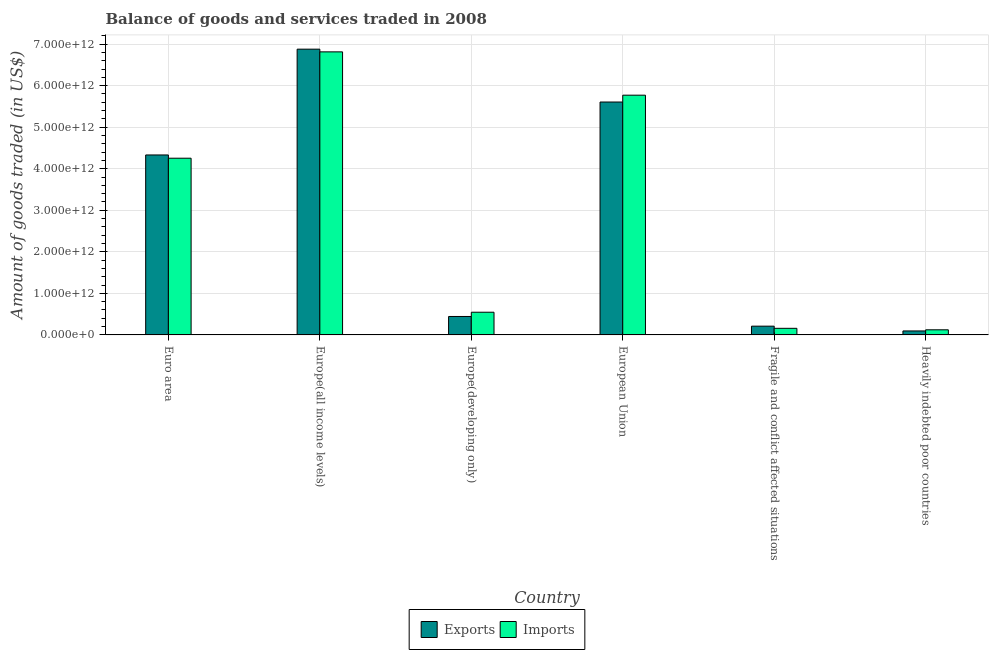How many different coloured bars are there?
Offer a terse response. 2. Are the number of bars on each tick of the X-axis equal?
Provide a short and direct response. Yes. How many bars are there on the 4th tick from the right?
Provide a short and direct response. 2. What is the label of the 1st group of bars from the left?
Your answer should be compact. Euro area. In how many cases, is the number of bars for a given country not equal to the number of legend labels?
Offer a very short reply. 0. What is the amount of goods exported in Europe(all income levels)?
Your response must be concise. 6.88e+12. Across all countries, what is the maximum amount of goods imported?
Keep it short and to the point. 6.81e+12. Across all countries, what is the minimum amount of goods exported?
Offer a terse response. 9.56e+1. In which country was the amount of goods exported maximum?
Make the answer very short. Europe(all income levels). In which country was the amount of goods imported minimum?
Your answer should be very brief. Heavily indebted poor countries. What is the total amount of goods imported in the graph?
Your answer should be very brief. 1.77e+13. What is the difference between the amount of goods exported in Europe(developing only) and that in European Union?
Offer a very short reply. -5.16e+12. What is the difference between the amount of goods exported in Euro area and the amount of goods imported in European Union?
Provide a short and direct response. -1.44e+12. What is the average amount of goods exported per country?
Keep it short and to the point. 2.93e+12. What is the difference between the amount of goods exported and amount of goods imported in Fragile and conflict affected situations?
Offer a terse response. 5.19e+1. What is the ratio of the amount of goods imported in European Union to that in Fragile and conflict affected situations?
Keep it short and to the point. 36.34. Is the difference between the amount of goods exported in Europe(all income levels) and Fragile and conflict affected situations greater than the difference between the amount of goods imported in Europe(all income levels) and Fragile and conflict affected situations?
Your answer should be very brief. Yes. What is the difference between the highest and the second highest amount of goods exported?
Your answer should be compact. 1.27e+12. What is the difference between the highest and the lowest amount of goods imported?
Give a very brief answer. 6.69e+12. What does the 2nd bar from the left in Europe(all income levels) represents?
Your answer should be very brief. Imports. What does the 2nd bar from the right in European Union represents?
Provide a succinct answer. Exports. How many bars are there?
Give a very brief answer. 12. How many countries are there in the graph?
Offer a very short reply. 6. What is the difference between two consecutive major ticks on the Y-axis?
Keep it short and to the point. 1.00e+12. Where does the legend appear in the graph?
Offer a very short reply. Bottom center. How many legend labels are there?
Offer a terse response. 2. What is the title of the graph?
Provide a succinct answer. Balance of goods and services traded in 2008. Does "Female labor force" appear as one of the legend labels in the graph?
Ensure brevity in your answer.  No. What is the label or title of the X-axis?
Ensure brevity in your answer.  Country. What is the label or title of the Y-axis?
Keep it short and to the point. Amount of goods traded (in US$). What is the Amount of goods traded (in US$) of Exports in Euro area?
Offer a very short reply. 4.33e+12. What is the Amount of goods traded (in US$) in Imports in Euro area?
Offer a terse response. 4.25e+12. What is the Amount of goods traded (in US$) of Exports in Europe(all income levels)?
Your answer should be compact. 6.88e+12. What is the Amount of goods traded (in US$) in Imports in Europe(all income levels)?
Offer a terse response. 6.81e+12. What is the Amount of goods traded (in US$) in Exports in Europe(developing only)?
Offer a terse response. 4.44e+11. What is the Amount of goods traded (in US$) of Imports in Europe(developing only)?
Offer a very short reply. 5.46e+11. What is the Amount of goods traded (in US$) in Exports in European Union?
Offer a terse response. 5.61e+12. What is the Amount of goods traded (in US$) of Imports in European Union?
Offer a very short reply. 5.77e+12. What is the Amount of goods traded (in US$) of Exports in Fragile and conflict affected situations?
Provide a succinct answer. 2.11e+11. What is the Amount of goods traded (in US$) in Imports in Fragile and conflict affected situations?
Offer a terse response. 1.59e+11. What is the Amount of goods traded (in US$) in Exports in Heavily indebted poor countries?
Your answer should be very brief. 9.56e+1. What is the Amount of goods traded (in US$) in Imports in Heavily indebted poor countries?
Your response must be concise. 1.23e+11. Across all countries, what is the maximum Amount of goods traded (in US$) in Exports?
Your answer should be compact. 6.88e+12. Across all countries, what is the maximum Amount of goods traded (in US$) of Imports?
Give a very brief answer. 6.81e+12. Across all countries, what is the minimum Amount of goods traded (in US$) of Exports?
Offer a very short reply. 9.56e+1. Across all countries, what is the minimum Amount of goods traded (in US$) of Imports?
Offer a very short reply. 1.23e+11. What is the total Amount of goods traded (in US$) in Exports in the graph?
Keep it short and to the point. 1.76e+13. What is the total Amount of goods traded (in US$) of Imports in the graph?
Your response must be concise. 1.77e+13. What is the difference between the Amount of goods traded (in US$) of Exports in Euro area and that in Europe(all income levels)?
Give a very brief answer. -2.55e+12. What is the difference between the Amount of goods traded (in US$) in Imports in Euro area and that in Europe(all income levels)?
Provide a short and direct response. -2.56e+12. What is the difference between the Amount of goods traded (in US$) of Exports in Euro area and that in Europe(developing only)?
Keep it short and to the point. 3.89e+12. What is the difference between the Amount of goods traded (in US$) of Imports in Euro area and that in Europe(developing only)?
Ensure brevity in your answer.  3.71e+12. What is the difference between the Amount of goods traded (in US$) of Exports in Euro area and that in European Union?
Your answer should be very brief. -1.27e+12. What is the difference between the Amount of goods traded (in US$) of Imports in Euro area and that in European Union?
Your answer should be very brief. -1.52e+12. What is the difference between the Amount of goods traded (in US$) of Exports in Euro area and that in Fragile and conflict affected situations?
Give a very brief answer. 4.12e+12. What is the difference between the Amount of goods traded (in US$) of Imports in Euro area and that in Fragile and conflict affected situations?
Make the answer very short. 4.09e+12. What is the difference between the Amount of goods traded (in US$) of Exports in Euro area and that in Heavily indebted poor countries?
Provide a succinct answer. 4.24e+12. What is the difference between the Amount of goods traded (in US$) in Imports in Euro area and that in Heavily indebted poor countries?
Make the answer very short. 4.13e+12. What is the difference between the Amount of goods traded (in US$) in Exports in Europe(all income levels) and that in Europe(developing only)?
Offer a terse response. 6.43e+12. What is the difference between the Amount of goods traded (in US$) of Imports in Europe(all income levels) and that in Europe(developing only)?
Make the answer very short. 6.27e+12. What is the difference between the Amount of goods traded (in US$) of Exports in Europe(all income levels) and that in European Union?
Your response must be concise. 1.27e+12. What is the difference between the Amount of goods traded (in US$) of Imports in Europe(all income levels) and that in European Union?
Offer a terse response. 1.04e+12. What is the difference between the Amount of goods traded (in US$) in Exports in Europe(all income levels) and that in Fragile and conflict affected situations?
Make the answer very short. 6.67e+12. What is the difference between the Amount of goods traded (in US$) in Imports in Europe(all income levels) and that in Fragile and conflict affected situations?
Make the answer very short. 6.65e+12. What is the difference between the Amount of goods traded (in US$) in Exports in Europe(all income levels) and that in Heavily indebted poor countries?
Your answer should be compact. 6.78e+12. What is the difference between the Amount of goods traded (in US$) in Imports in Europe(all income levels) and that in Heavily indebted poor countries?
Your answer should be very brief. 6.69e+12. What is the difference between the Amount of goods traded (in US$) of Exports in Europe(developing only) and that in European Union?
Your answer should be very brief. -5.16e+12. What is the difference between the Amount of goods traded (in US$) in Imports in Europe(developing only) and that in European Union?
Provide a succinct answer. -5.22e+12. What is the difference between the Amount of goods traded (in US$) of Exports in Europe(developing only) and that in Fragile and conflict affected situations?
Make the answer very short. 2.33e+11. What is the difference between the Amount of goods traded (in US$) in Imports in Europe(developing only) and that in Fragile and conflict affected situations?
Your answer should be very brief. 3.87e+11. What is the difference between the Amount of goods traded (in US$) of Exports in Europe(developing only) and that in Heavily indebted poor countries?
Offer a very short reply. 3.48e+11. What is the difference between the Amount of goods traded (in US$) of Imports in Europe(developing only) and that in Heavily indebted poor countries?
Your response must be concise. 4.23e+11. What is the difference between the Amount of goods traded (in US$) of Exports in European Union and that in Fragile and conflict affected situations?
Offer a very short reply. 5.39e+12. What is the difference between the Amount of goods traded (in US$) of Imports in European Union and that in Fragile and conflict affected situations?
Give a very brief answer. 5.61e+12. What is the difference between the Amount of goods traded (in US$) in Exports in European Union and that in Heavily indebted poor countries?
Provide a succinct answer. 5.51e+12. What is the difference between the Amount of goods traded (in US$) of Imports in European Union and that in Heavily indebted poor countries?
Keep it short and to the point. 5.65e+12. What is the difference between the Amount of goods traded (in US$) in Exports in Fragile and conflict affected situations and that in Heavily indebted poor countries?
Make the answer very short. 1.15e+11. What is the difference between the Amount of goods traded (in US$) of Imports in Fragile and conflict affected situations and that in Heavily indebted poor countries?
Provide a short and direct response. 3.57e+1. What is the difference between the Amount of goods traded (in US$) of Exports in Euro area and the Amount of goods traded (in US$) of Imports in Europe(all income levels)?
Provide a succinct answer. -2.48e+12. What is the difference between the Amount of goods traded (in US$) in Exports in Euro area and the Amount of goods traded (in US$) in Imports in Europe(developing only)?
Your answer should be very brief. 3.79e+12. What is the difference between the Amount of goods traded (in US$) in Exports in Euro area and the Amount of goods traded (in US$) in Imports in European Union?
Ensure brevity in your answer.  -1.44e+12. What is the difference between the Amount of goods traded (in US$) in Exports in Euro area and the Amount of goods traded (in US$) in Imports in Fragile and conflict affected situations?
Give a very brief answer. 4.17e+12. What is the difference between the Amount of goods traded (in US$) in Exports in Euro area and the Amount of goods traded (in US$) in Imports in Heavily indebted poor countries?
Offer a terse response. 4.21e+12. What is the difference between the Amount of goods traded (in US$) of Exports in Europe(all income levels) and the Amount of goods traded (in US$) of Imports in Europe(developing only)?
Your response must be concise. 6.33e+12. What is the difference between the Amount of goods traded (in US$) in Exports in Europe(all income levels) and the Amount of goods traded (in US$) in Imports in European Union?
Your answer should be very brief. 1.11e+12. What is the difference between the Amount of goods traded (in US$) in Exports in Europe(all income levels) and the Amount of goods traded (in US$) in Imports in Fragile and conflict affected situations?
Offer a very short reply. 6.72e+12. What is the difference between the Amount of goods traded (in US$) in Exports in Europe(all income levels) and the Amount of goods traded (in US$) in Imports in Heavily indebted poor countries?
Ensure brevity in your answer.  6.75e+12. What is the difference between the Amount of goods traded (in US$) of Exports in Europe(developing only) and the Amount of goods traded (in US$) of Imports in European Union?
Make the answer very short. -5.33e+12. What is the difference between the Amount of goods traded (in US$) in Exports in Europe(developing only) and the Amount of goods traded (in US$) in Imports in Fragile and conflict affected situations?
Make the answer very short. 2.85e+11. What is the difference between the Amount of goods traded (in US$) of Exports in Europe(developing only) and the Amount of goods traded (in US$) of Imports in Heavily indebted poor countries?
Keep it short and to the point. 3.21e+11. What is the difference between the Amount of goods traded (in US$) of Exports in European Union and the Amount of goods traded (in US$) of Imports in Fragile and conflict affected situations?
Provide a succinct answer. 5.45e+12. What is the difference between the Amount of goods traded (in US$) in Exports in European Union and the Amount of goods traded (in US$) in Imports in Heavily indebted poor countries?
Ensure brevity in your answer.  5.48e+12. What is the difference between the Amount of goods traded (in US$) in Exports in Fragile and conflict affected situations and the Amount of goods traded (in US$) in Imports in Heavily indebted poor countries?
Ensure brevity in your answer.  8.76e+1. What is the average Amount of goods traded (in US$) in Exports per country?
Ensure brevity in your answer.  2.93e+12. What is the average Amount of goods traded (in US$) of Imports per country?
Make the answer very short. 2.94e+12. What is the difference between the Amount of goods traded (in US$) in Exports and Amount of goods traded (in US$) in Imports in Euro area?
Provide a succinct answer. 7.85e+1. What is the difference between the Amount of goods traded (in US$) of Exports and Amount of goods traded (in US$) of Imports in Europe(all income levels)?
Keep it short and to the point. 6.52e+1. What is the difference between the Amount of goods traded (in US$) of Exports and Amount of goods traded (in US$) of Imports in Europe(developing only)?
Keep it short and to the point. -1.02e+11. What is the difference between the Amount of goods traded (in US$) of Exports and Amount of goods traded (in US$) of Imports in European Union?
Your answer should be compact. -1.65e+11. What is the difference between the Amount of goods traded (in US$) of Exports and Amount of goods traded (in US$) of Imports in Fragile and conflict affected situations?
Provide a succinct answer. 5.19e+1. What is the difference between the Amount of goods traded (in US$) in Exports and Amount of goods traded (in US$) in Imports in Heavily indebted poor countries?
Make the answer very short. -2.75e+1. What is the ratio of the Amount of goods traded (in US$) of Exports in Euro area to that in Europe(all income levels)?
Make the answer very short. 0.63. What is the ratio of the Amount of goods traded (in US$) in Imports in Euro area to that in Europe(all income levels)?
Offer a terse response. 0.62. What is the ratio of the Amount of goods traded (in US$) of Exports in Euro area to that in Europe(developing only)?
Offer a terse response. 9.76. What is the ratio of the Amount of goods traded (in US$) in Imports in Euro area to that in Europe(developing only)?
Provide a short and direct response. 7.79. What is the ratio of the Amount of goods traded (in US$) in Exports in Euro area to that in European Union?
Keep it short and to the point. 0.77. What is the ratio of the Amount of goods traded (in US$) in Imports in Euro area to that in European Union?
Ensure brevity in your answer.  0.74. What is the ratio of the Amount of goods traded (in US$) in Exports in Euro area to that in Fragile and conflict affected situations?
Your answer should be compact. 20.56. What is the ratio of the Amount of goods traded (in US$) of Imports in Euro area to that in Fragile and conflict affected situations?
Give a very brief answer. 26.79. What is the ratio of the Amount of goods traded (in US$) in Exports in Euro area to that in Heavily indebted poor countries?
Ensure brevity in your answer.  45.3. What is the ratio of the Amount of goods traded (in US$) in Imports in Euro area to that in Heavily indebted poor countries?
Provide a succinct answer. 34.55. What is the ratio of the Amount of goods traded (in US$) in Exports in Europe(all income levels) to that in Europe(developing only)?
Give a very brief answer. 15.5. What is the ratio of the Amount of goods traded (in US$) in Imports in Europe(all income levels) to that in Europe(developing only)?
Make the answer very short. 12.48. What is the ratio of the Amount of goods traded (in US$) of Exports in Europe(all income levels) to that in European Union?
Offer a very short reply. 1.23. What is the ratio of the Amount of goods traded (in US$) of Imports in Europe(all income levels) to that in European Union?
Give a very brief answer. 1.18. What is the ratio of the Amount of goods traded (in US$) of Exports in Europe(all income levels) to that in Fragile and conflict affected situations?
Make the answer very short. 32.65. What is the ratio of the Amount of goods traded (in US$) of Imports in Europe(all income levels) to that in Fragile and conflict affected situations?
Give a very brief answer. 42.91. What is the ratio of the Amount of goods traded (in US$) of Exports in Europe(all income levels) to that in Heavily indebted poor countries?
Your response must be concise. 71.94. What is the ratio of the Amount of goods traded (in US$) of Imports in Europe(all income levels) to that in Heavily indebted poor countries?
Your response must be concise. 55.35. What is the ratio of the Amount of goods traded (in US$) of Exports in Europe(developing only) to that in European Union?
Offer a terse response. 0.08. What is the ratio of the Amount of goods traded (in US$) in Imports in Europe(developing only) to that in European Union?
Ensure brevity in your answer.  0.09. What is the ratio of the Amount of goods traded (in US$) in Exports in Europe(developing only) to that in Fragile and conflict affected situations?
Your response must be concise. 2.11. What is the ratio of the Amount of goods traded (in US$) of Imports in Europe(developing only) to that in Fragile and conflict affected situations?
Your answer should be compact. 3.44. What is the ratio of the Amount of goods traded (in US$) of Exports in Europe(developing only) to that in Heavily indebted poor countries?
Provide a succinct answer. 4.64. What is the ratio of the Amount of goods traded (in US$) in Imports in Europe(developing only) to that in Heavily indebted poor countries?
Keep it short and to the point. 4.44. What is the ratio of the Amount of goods traded (in US$) in Exports in European Union to that in Fragile and conflict affected situations?
Offer a terse response. 26.61. What is the ratio of the Amount of goods traded (in US$) of Imports in European Union to that in Fragile and conflict affected situations?
Provide a succinct answer. 36.34. What is the ratio of the Amount of goods traded (in US$) in Exports in European Union to that in Heavily indebted poor countries?
Ensure brevity in your answer.  58.63. What is the ratio of the Amount of goods traded (in US$) in Imports in European Union to that in Heavily indebted poor countries?
Ensure brevity in your answer.  46.88. What is the ratio of the Amount of goods traded (in US$) of Exports in Fragile and conflict affected situations to that in Heavily indebted poor countries?
Provide a succinct answer. 2.2. What is the ratio of the Amount of goods traded (in US$) of Imports in Fragile and conflict affected situations to that in Heavily indebted poor countries?
Keep it short and to the point. 1.29. What is the difference between the highest and the second highest Amount of goods traded (in US$) in Exports?
Make the answer very short. 1.27e+12. What is the difference between the highest and the second highest Amount of goods traded (in US$) of Imports?
Offer a terse response. 1.04e+12. What is the difference between the highest and the lowest Amount of goods traded (in US$) in Exports?
Keep it short and to the point. 6.78e+12. What is the difference between the highest and the lowest Amount of goods traded (in US$) in Imports?
Your response must be concise. 6.69e+12. 